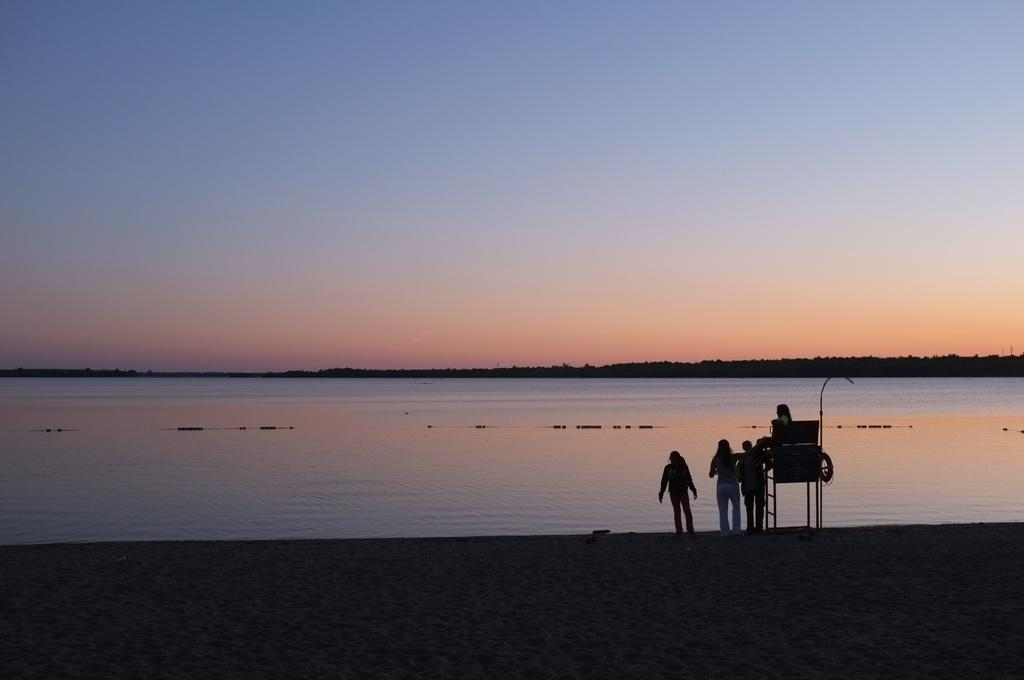What is the person in the image doing? There is a person sitting in the image. How many people are standing in the image? There are three people standing in the image. What object can be seen in the image that is used for climbing? There is a ladder in the image. What natural element is visible in the image? There is water visible in the image. What type of vegetation is present in the image? There are trees in the image. What is visible in the background of the image? The sky is visible in the background of the image. What type of seat is the person sitting on in the image? There is no seat mentioned in the image; the person is sitting on the ground or another surface. What type of war is depicted in the image? There is no war depicted in the image; it features people, a ladder, water, trees, and the sky. 